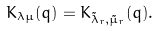<formula> <loc_0><loc_0><loc_500><loc_500>K _ { \lambda \mu } ( q ) = K _ { \tilde { \lambda } _ { r } , \tilde { \mu } _ { r } } ( q ) .</formula> 